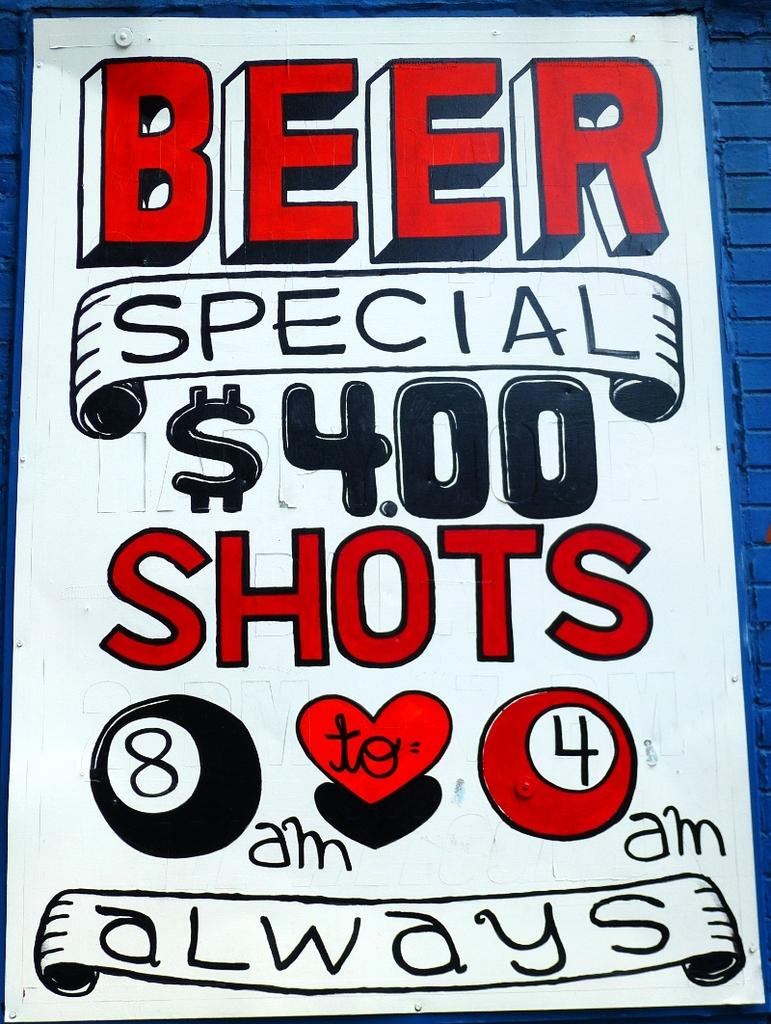<image>
Describe the image concisely. A black, white, and red which reads "Beer Special $4.00 shots, 8 am to 4 am always" is hung on a blue building. 